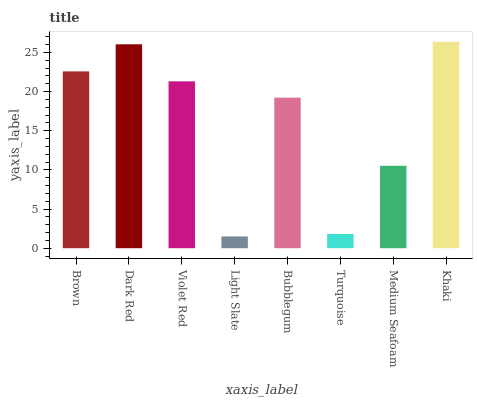Is Dark Red the minimum?
Answer yes or no. No. Is Dark Red the maximum?
Answer yes or no. No. Is Dark Red greater than Brown?
Answer yes or no. Yes. Is Brown less than Dark Red?
Answer yes or no. Yes. Is Brown greater than Dark Red?
Answer yes or no. No. Is Dark Red less than Brown?
Answer yes or no. No. Is Violet Red the high median?
Answer yes or no. Yes. Is Bubblegum the low median?
Answer yes or no. Yes. Is Light Slate the high median?
Answer yes or no. No. Is Violet Red the low median?
Answer yes or no. No. 